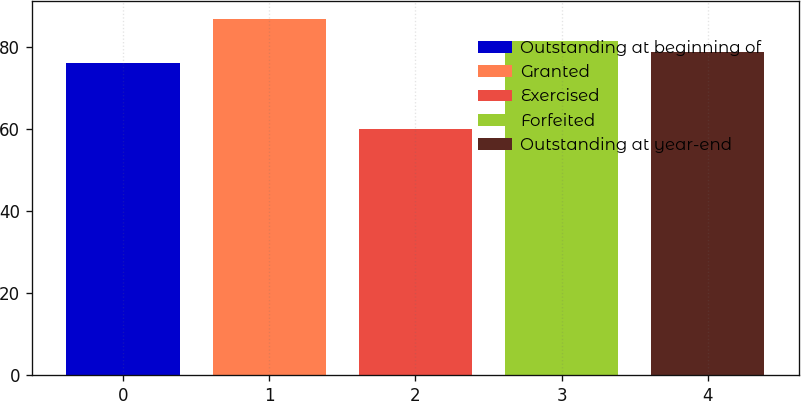Convert chart to OTSL. <chart><loc_0><loc_0><loc_500><loc_500><bar_chart><fcel>Outstanding at beginning of<fcel>Granted<fcel>Exercised<fcel>Forfeited<fcel>Outstanding at year-end<nl><fcel>76.1<fcel>86.86<fcel>60.1<fcel>81.46<fcel>78.78<nl></chart> 